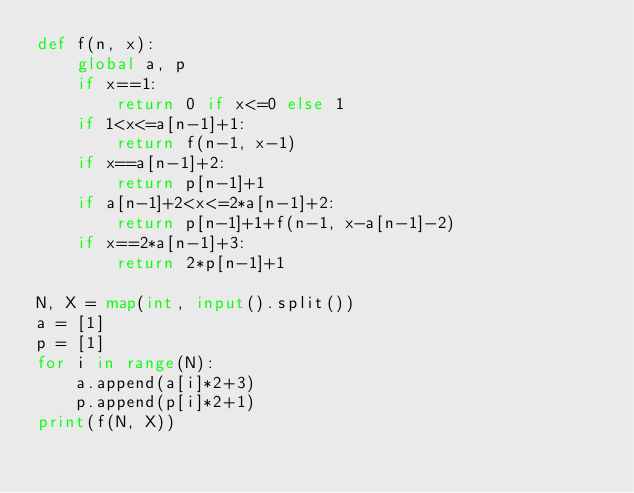<code> <loc_0><loc_0><loc_500><loc_500><_Python_>def f(n, x):
    global a, p
    if x==1:
        return 0 if x<=0 else 1
    if 1<x<=a[n-1]+1: 
        return f(n-1, x-1)
    if x==a[n-1]+2: 
        return p[n-1]+1
    if a[n-1]+2<x<=2*a[n-1]+2: 
        return p[n-1]+1+f(n-1, x-a[n-1]-2)
    if x==2*a[n-1]+3:
        return 2*p[n-1]+1

N, X = map(int, input().split())
a = [1]
p = [1]
for i in range(N):
    a.append(a[i]*2+3)
    p.append(p[i]*2+1)
print(f(N, X))</code> 